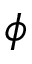<formula> <loc_0><loc_0><loc_500><loc_500>\phi</formula> 